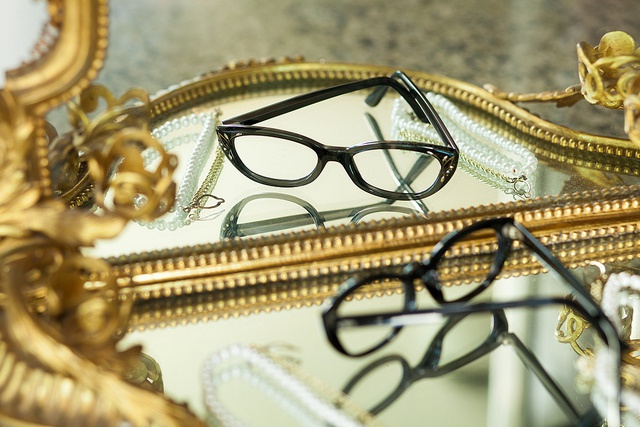Describe the objects in this image and their specific colors. I can see various objects in this image with different colors. 